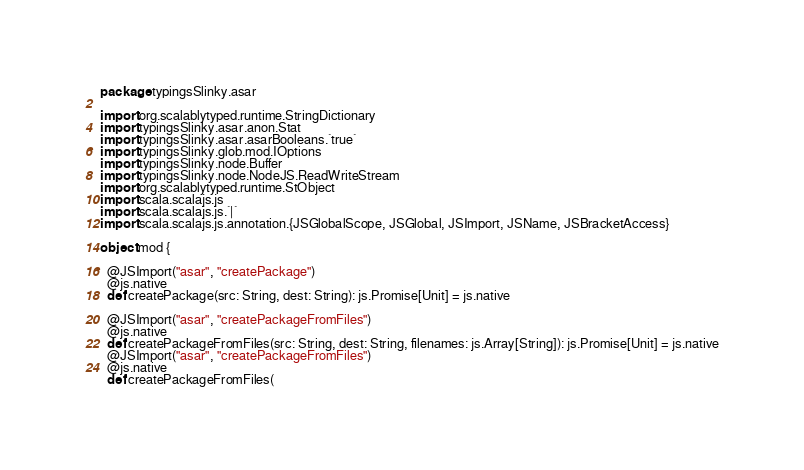Convert code to text. <code><loc_0><loc_0><loc_500><loc_500><_Scala_>package typingsSlinky.asar

import org.scalablytyped.runtime.StringDictionary
import typingsSlinky.asar.anon.Stat
import typingsSlinky.asar.asarBooleans.`true`
import typingsSlinky.glob.mod.IOptions
import typingsSlinky.node.Buffer
import typingsSlinky.node.NodeJS.ReadWriteStream
import org.scalablytyped.runtime.StObject
import scala.scalajs.js
import scala.scalajs.js.`|`
import scala.scalajs.js.annotation.{JSGlobalScope, JSGlobal, JSImport, JSName, JSBracketAccess}

object mod {
  
  @JSImport("asar", "createPackage")
  @js.native
  def createPackage(src: String, dest: String): js.Promise[Unit] = js.native
  
  @JSImport("asar", "createPackageFromFiles")
  @js.native
  def createPackageFromFiles(src: String, dest: String, filenames: js.Array[String]): js.Promise[Unit] = js.native
  @JSImport("asar", "createPackageFromFiles")
  @js.native
  def createPackageFromFiles(</code> 